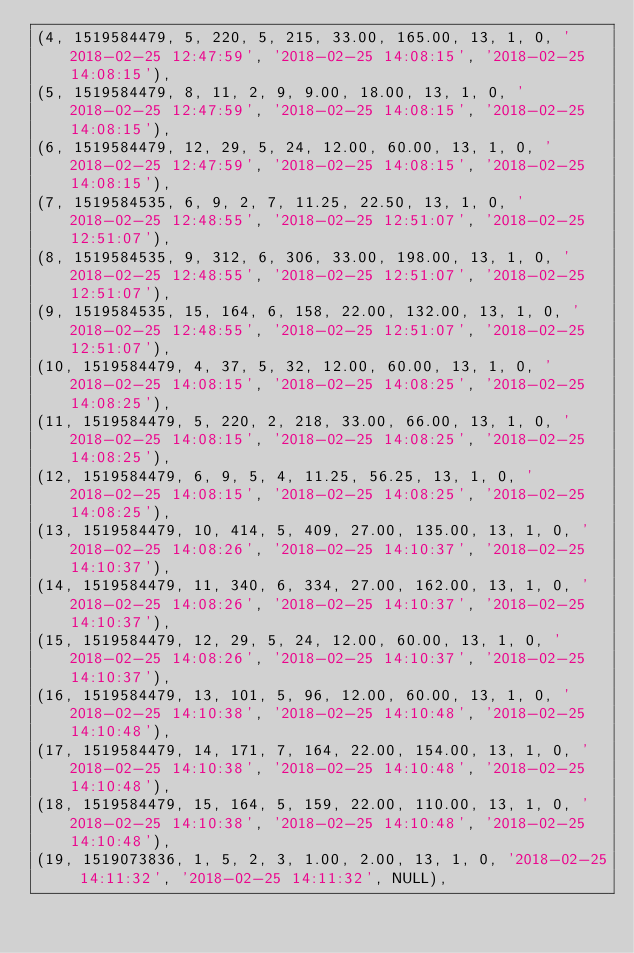<code> <loc_0><loc_0><loc_500><loc_500><_SQL_>(4, 1519584479, 5, 220, 5, 215, 33.00, 165.00, 13, 1, 0, '2018-02-25 12:47:59', '2018-02-25 14:08:15', '2018-02-25 14:08:15'),
(5, 1519584479, 8, 11, 2, 9, 9.00, 18.00, 13, 1, 0, '2018-02-25 12:47:59', '2018-02-25 14:08:15', '2018-02-25 14:08:15'),
(6, 1519584479, 12, 29, 5, 24, 12.00, 60.00, 13, 1, 0, '2018-02-25 12:47:59', '2018-02-25 14:08:15', '2018-02-25 14:08:15'),
(7, 1519584535, 6, 9, 2, 7, 11.25, 22.50, 13, 1, 0, '2018-02-25 12:48:55', '2018-02-25 12:51:07', '2018-02-25 12:51:07'),
(8, 1519584535, 9, 312, 6, 306, 33.00, 198.00, 13, 1, 0, '2018-02-25 12:48:55', '2018-02-25 12:51:07', '2018-02-25 12:51:07'),
(9, 1519584535, 15, 164, 6, 158, 22.00, 132.00, 13, 1, 0, '2018-02-25 12:48:55', '2018-02-25 12:51:07', '2018-02-25 12:51:07'),
(10, 1519584479, 4, 37, 5, 32, 12.00, 60.00, 13, 1, 0, '2018-02-25 14:08:15', '2018-02-25 14:08:25', '2018-02-25 14:08:25'),
(11, 1519584479, 5, 220, 2, 218, 33.00, 66.00, 13, 1, 0, '2018-02-25 14:08:15', '2018-02-25 14:08:25', '2018-02-25 14:08:25'),
(12, 1519584479, 6, 9, 5, 4, 11.25, 56.25, 13, 1, 0, '2018-02-25 14:08:15', '2018-02-25 14:08:25', '2018-02-25 14:08:25'),
(13, 1519584479, 10, 414, 5, 409, 27.00, 135.00, 13, 1, 0, '2018-02-25 14:08:26', '2018-02-25 14:10:37', '2018-02-25 14:10:37'),
(14, 1519584479, 11, 340, 6, 334, 27.00, 162.00, 13, 1, 0, '2018-02-25 14:08:26', '2018-02-25 14:10:37', '2018-02-25 14:10:37'),
(15, 1519584479, 12, 29, 5, 24, 12.00, 60.00, 13, 1, 0, '2018-02-25 14:08:26', '2018-02-25 14:10:37', '2018-02-25 14:10:37'),
(16, 1519584479, 13, 101, 5, 96, 12.00, 60.00, 13, 1, 0, '2018-02-25 14:10:38', '2018-02-25 14:10:48', '2018-02-25 14:10:48'),
(17, 1519584479, 14, 171, 7, 164, 22.00, 154.00, 13, 1, 0, '2018-02-25 14:10:38', '2018-02-25 14:10:48', '2018-02-25 14:10:48'),
(18, 1519584479, 15, 164, 5, 159, 22.00, 110.00, 13, 1, 0, '2018-02-25 14:10:38', '2018-02-25 14:10:48', '2018-02-25 14:10:48'),
(19, 1519073836, 1, 5, 2, 3, 1.00, 2.00, 13, 1, 0, '2018-02-25 14:11:32', '2018-02-25 14:11:32', NULL),</code> 